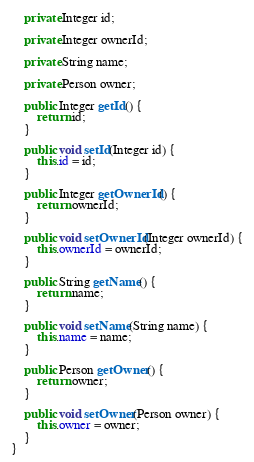<code> <loc_0><loc_0><loc_500><loc_500><_Java_>
    private Integer id;

    private Integer ownerId;

    private String name;

    private Person owner;

    public Integer getId() {
        return id;
    }

    public void setId(Integer id) {
        this.id = id;
    }

    public Integer getOwnerId() {
        return ownerId;
    }

    public void setOwnerId(Integer ownerId) {
        this.ownerId = ownerId;
    }

    public String getName() {
        return name;
    }

    public void setName(String name) {
        this.name = name;
    }

    public Person getOwner() {
        return owner;
    }

    public void setOwner(Person owner) {
        this.owner = owner;
    }
}
</code> 